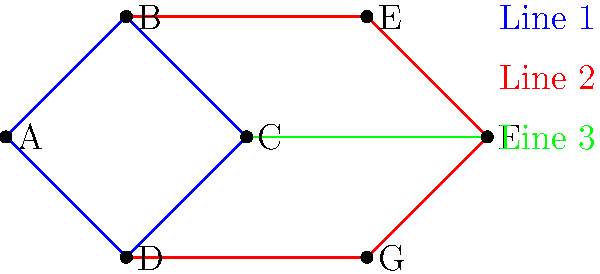In this simplified representation of London's underground tube system, how many different routes can a passenger take to travel from station A to station F without passing through the same station twice? To solve this problem, we need to follow these steps:

1. Identify all possible paths from A to F:
   a) A → B → E → F
   b) A → B → C → F
   c) A → D → G → F
   d) A → D → C → F

2. Count the number of unique paths:
   There are 4 distinct paths from A to F.

3. Verify that each path doesn't pass through the same station twice:
   All four paths identified satisfy this condition.

4. Consider alternative routes:
   There are no other possible routes that don't involve backtracking or passing through a station twice.

Therefore, there are 4 different routes a passenger can take from station A to station F without passing through the same station twice.
Answer: 4 